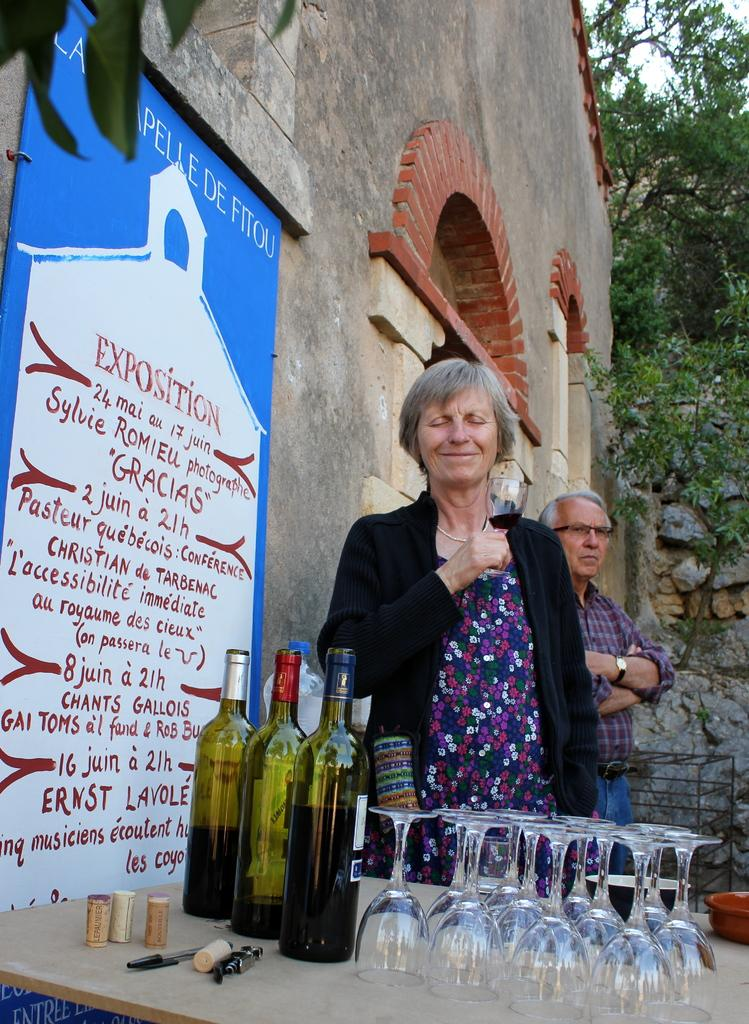What type of plant can be seen in the image? There is a tree in the image. What is hanging or attached to the tree? There is a banner in the image. What is the background of the image made of? There is a wall in the image. How many people are present in the image? There are two people standing in the image. What is on the table in the image? There are bottles and glasses on the table. Can you tell me how much salt is on the table in the image? There is no salt present on the table in the image. What type of underwear is hanging from the tree in the image? There is no underwear present in the image; it features a tree with a banner. 